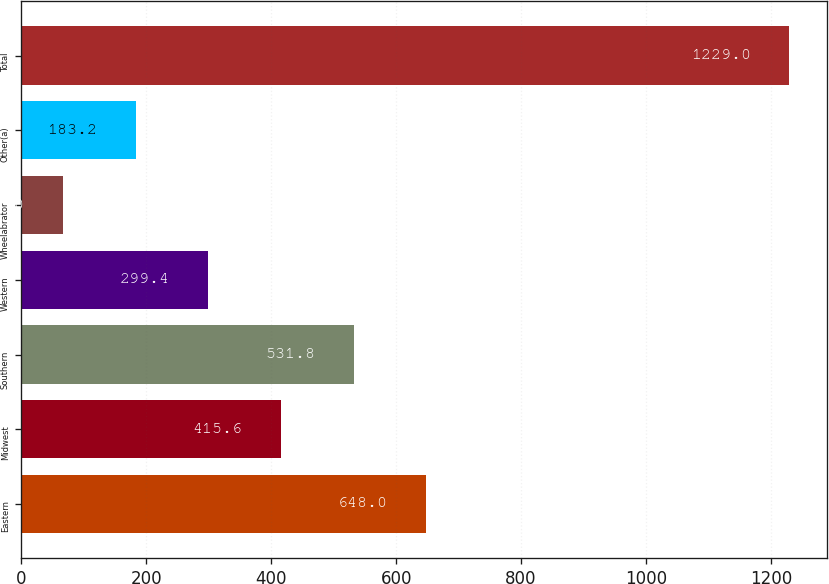<chart> <loc_0><loc_0><loc_500><loc_500><bar_chart><fcel>Eastern<fcel>Midwest<fcel>Southern<fcel>Western<fcel>Wheelabrator<fcel>Other(a)<fcel>Total<nl><fcel>648<fcel>415.6<fcel>531.8<fcel>299.4<fcel>67<fcel>183.2<fcel>1229<nl></chart> 